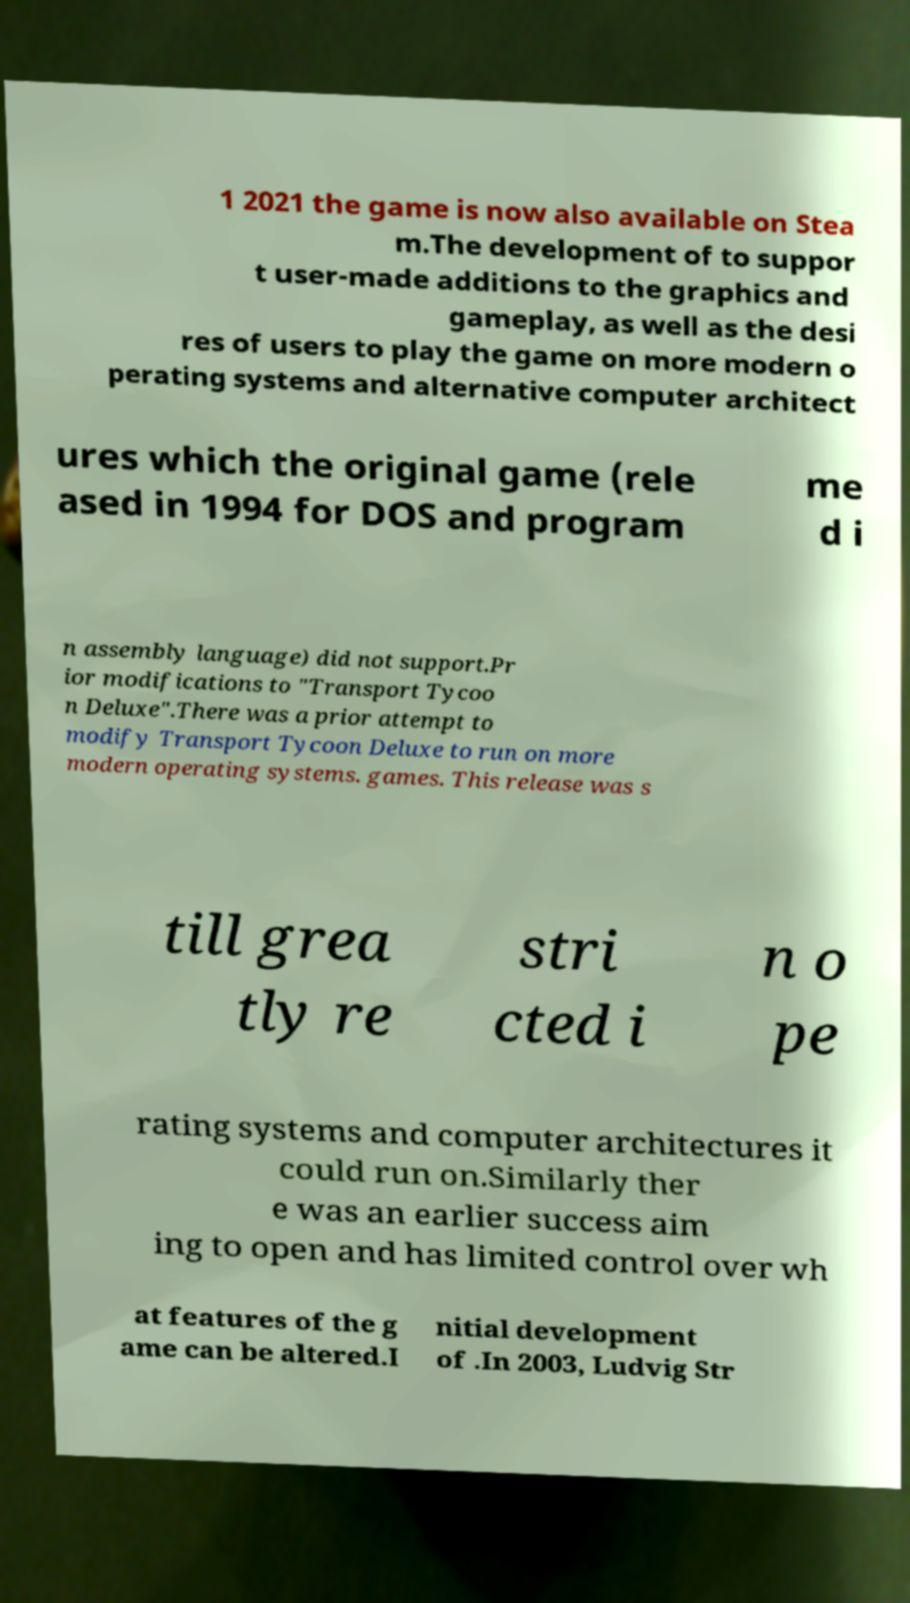Could you extract and type out the text from this image? 1 2021 the game is now also available on Stea m.The development of to suppor t user-made additions to the graphics and gameplay, as well as the desi res of users to play the game on more modern o perating systems and alternative computer architect ures which the original game (rele ased in 1994 for DOS and program me d i n assembly language) did not support.Pr ior modifications to "Transport Tycoo n Deluxe".There was a prior attempt to modify Transport Tycoon Deluxe to run on more modern operating systems. games. This release was s till grea tly re stri cted i n o pe rating systems and computer architectures it could run on.Similarly ther e was an earlier success aim ing to open and has limited control over wh at features of the g ame can be altered.I nitial development of .In 2003, Ludvig Str 